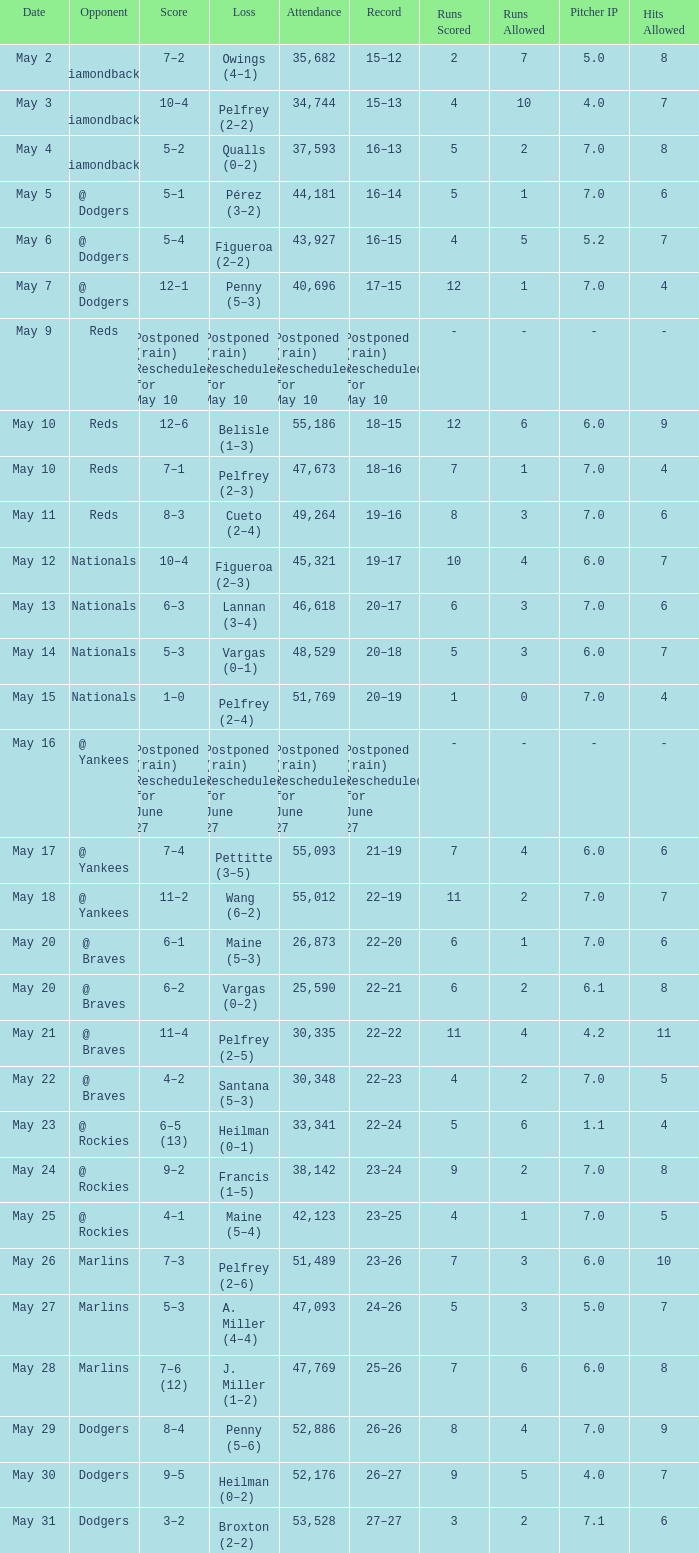Attendance of 30,335 had what record? 22–22. 